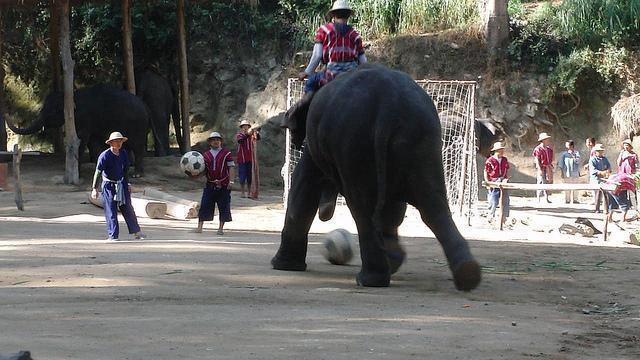What is the elephant doing with the ball?
Choose the correct response, then elucidate: 'Answer: answer
Rationale: rationale.'
Options: Destroying it, eating it, kicking it, throwing it. Answer: kicking it.
Rationale: The elephant is kicking the ball. What is this this elephant doing?
Choose the correct response, then elucidate: 'Answer: answer
Rationale: rationale.'
Options: Drinking, painting, playing soccer, eating. Answer: playing soccer.
Rationale: The elephant is kicking a soccer ball. 